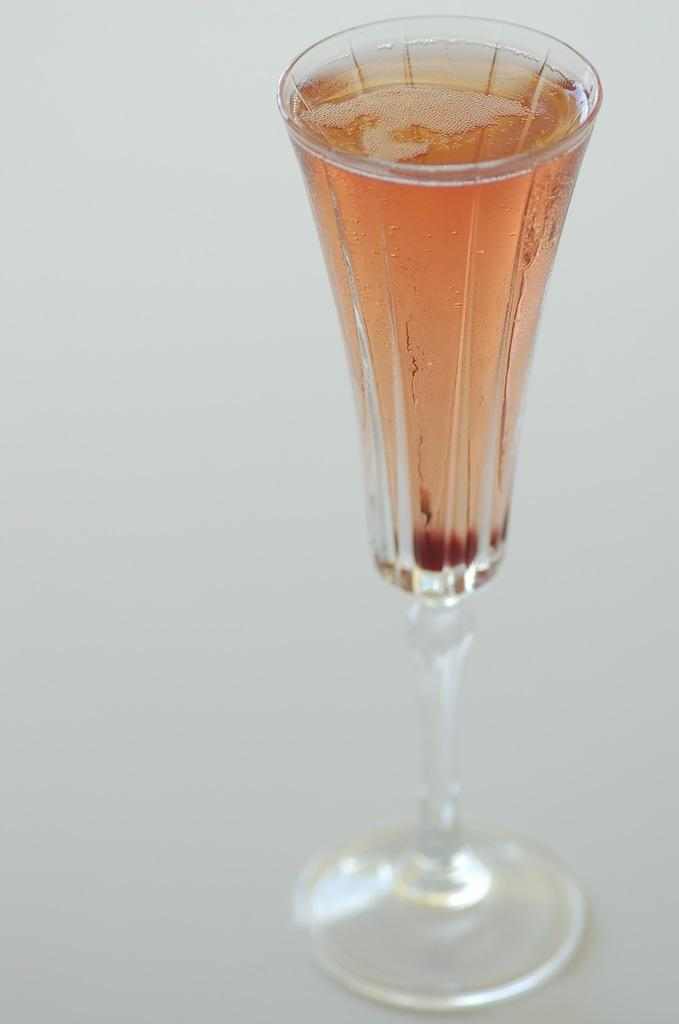What is in the glass that is visible in the image? The glass is filled with a drink. What can be seen in the background of the image? The background of the image is white. How many girls are present in the image? There are no girls present in the image; it only features a glass filled with a drink and a white background. 